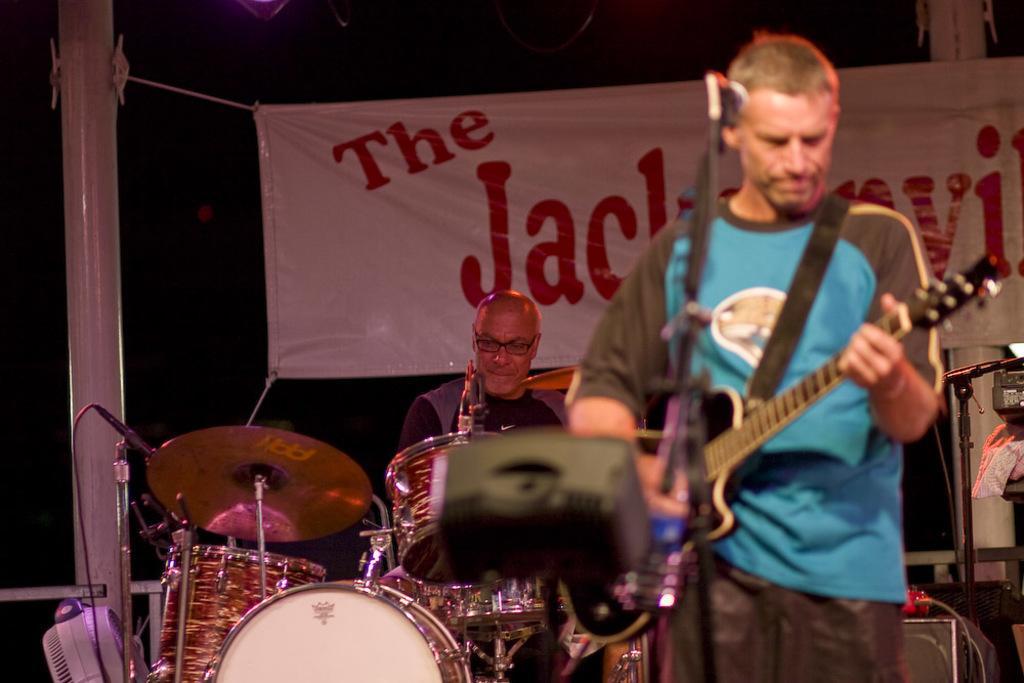Can you describe this image briefly? In this image there are two men playing guitar and drums. In the front, the man wearing blue t-shirt is playing guitar. In the back, the man sitting is playing drums. In the background, there is a banner. 